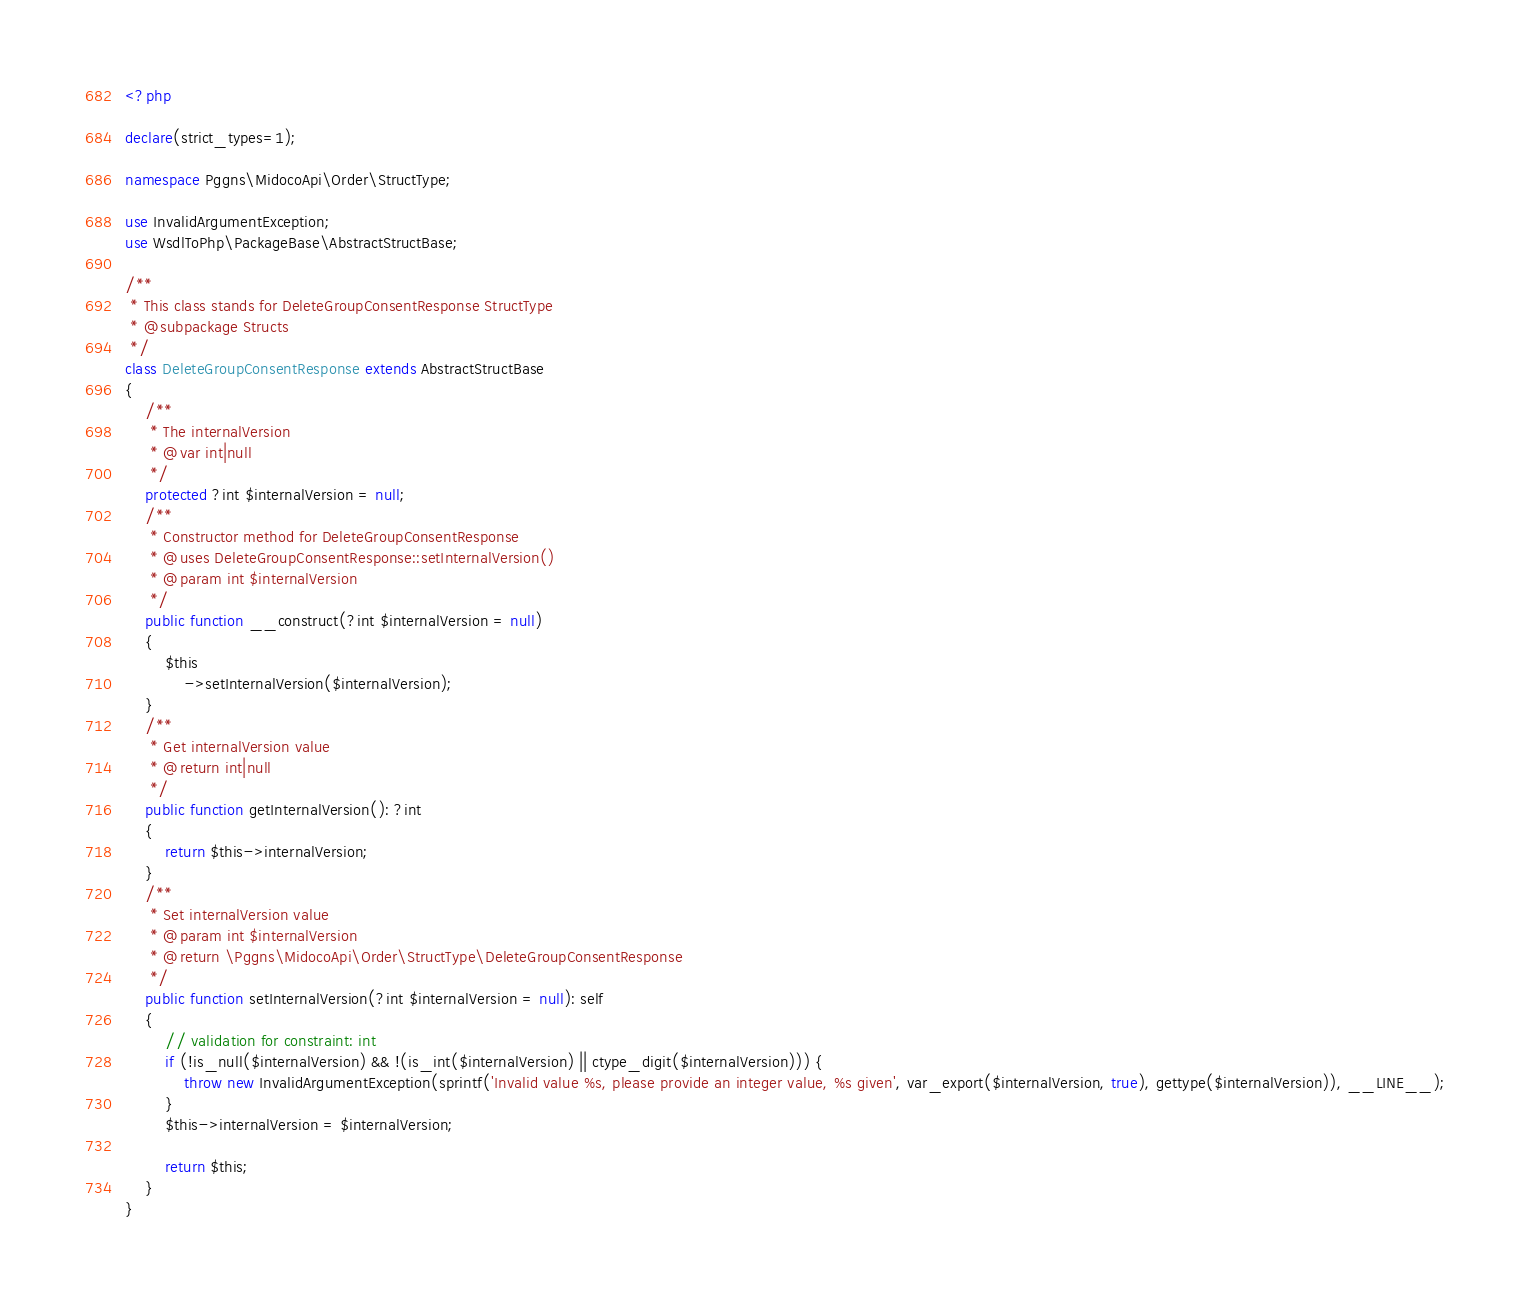<code> <loc_0><loc_0><loc_500><loc_500><_PHP_><?php

declare(strict_types=1);

namespace Pggns\MidocoApi\Order\StructType;

use InvalidArgumentException;
use WsdlToPhp\PackageBase\AbstractStructBase;

/**
 * This class stands for DeleteGroupConsentResponse StructType
 * @subpackage Structs
 */
class DeleteGroupConsentResponse extends AbstractStructBase
{
    /**
     * The internalVersion
     * @var int|null
     */
    protected ?int $internalVersion = null;
    /**
     * Constructor method for DeleteGroupConsentResponse
     * @uses DeleteGroupConsentResponse::setInternalVersion()
     * @param int $internalVersion
     */
    public function __construct(?int $internalVersion = null)
    {
        $this
            ->setInternalVersion($internalVersion);
    }
    /**
     * Get internalVersion value
     * @return int|null
     */
    public function getInternalVersion(): ?int
    {
        return $this->internalVersion;
    }
    /**
     * Set internalVersion value
     * @param int $internalVersion
     * @return \Pggns\MidocoApi\Order\StructType\DeleteGroupConsentResponse
     */
    public function setInternalVersion(?int $internalVersion = null): self
    {
        // validation for constraint: int
        if (!is_null($internalVersion) && !(is_int($internalVersion) || ctype_digit($internalVersion))) {
            throw new InvalidArgumentException(sprintf('Invalid value %s, please provide an integer value, %s given', var_export($internalVersion, true), gettype($internalVersion)), __LINE__);
        }
        $this->internalVersion = $internalVersion;
        
        return $this;
    }
}
</code> 